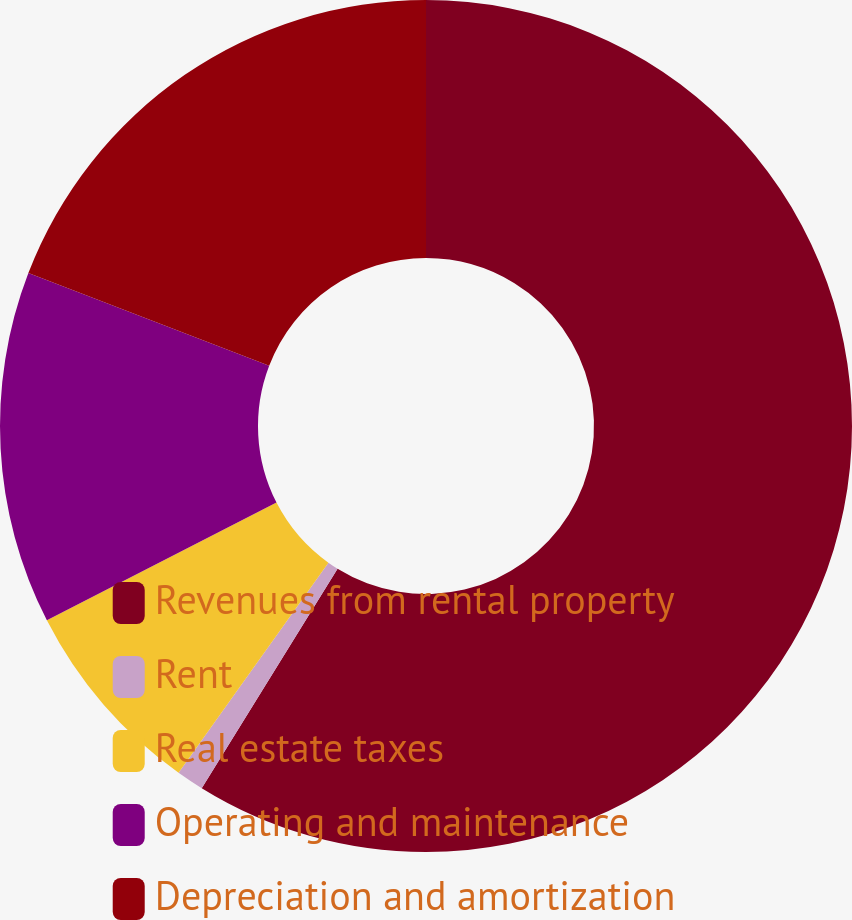Convert chart. <chart><loc_0><loc_0><loc_500><loc_500><pie_chart><fcel>Revenues from rental property<fcel>Rent<fcel>Real estate taxes<fcel>Operating and maintenance<fcel>Depreciation and amortization<nl><fcel>58.83%<fcel>1.04%<fcel>7.6%<fcel>13.38%<fcel>19.16%<nl></chart> 